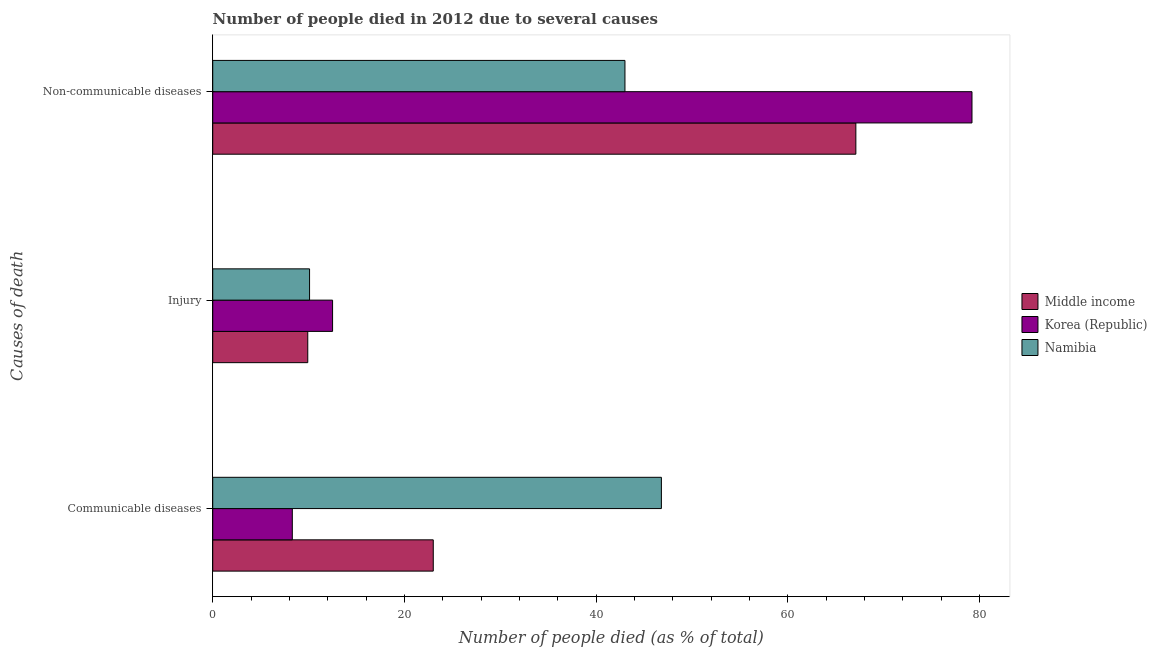How many different coloured bars are there?
Keep it short and to the point. 3. How many groups of bars are there?
Keep it short and to the point. 3. Are the number of bars per tick equal to the number of legend labels?
Keep it short and to the point. Yes. Are the number of bars on each tick of the Y-axis equal?
Your answer should be compact. Yes. How many bars are there on the 3rd tick from the bottom?
Your answer should be compact. 3. What is the label of the 2nd group of bars from the top?
Provide a short and direct response. Injury. What is the number of people who died of injury in Middle income?
Your answer should be compact. 9.91. In which country was the number of people who died of injury minimum?
Provide a succinct answer. Middle income. What is the total number of people who died of injury in the graph?
Give a very brief answer. 32.51. What is the difference between the number of people who died of communicable diseases in Korea (Republic) and that in Middle income?
Provide a succinct answer. -14.7. What is the difference between the number of people who died of injury in Korea (Republic) and the number of people who dies of non-communicable diseases in Middle income?
Offer a terse response. -54.59. What is the average number of people who died of communicable diseases per country?
Your answer should be very brief. 26.03. What is the difference between the number of people who dies of non-communicable diseases and number of people who died of communicable diseases in Korea (Republic)?
Your answer should be very brief. 70.9. In how many countries, is the number of people who died of injury greater than 4 %?
Keep it short and to the point. 3. What is the ratio of the number of people who dies of non-communicable diseases in Korea (Republic) to that in Middle income?
Provide a succinct answer. 1.18. What is the difference between the highest and the second highest number of people who died of communicable diseases?
Provide a short and direct response. 23.8. What is the difference between the highest and the lowest number of people who died of injury?
Make the answer very short. 2.59. In how many countries, is the number of people who dies of non-communicable diseases greater than the average number of people who dies of non-communicable diseases taken over all countries?
Offer a very short reply. 2. Is the sum of the number of people who died of injury in Middle income and Korea (Republic) greater than the maximum number of people who died of communicable diseases across all countries?
Keep it short and to the point. No. What does the 3rd bar from the top in Communicable diseases represents?
Your answer should be very brief. Middle income. What does the 2nd bar from the bottom in Communicable diseases represents?
Your answer should be very brief. Korea (Republic). Is it the case that in every country, the sum of the number of people who died of communicable diseases and number of people who died of injury is greater than the number of people who dies of non-communicable diseases?
Your response must be concise. No. Are all the bars in the graph horizontal?
Ensure brevity in your answer.  Yes. What is the difference between two consecutive major ticks on the X-axis?
Make the answer very short. 20. Does the graph contain any zero values?
Offer a very short reply. No. Does the graph contain grids?
Provide a succinct answer. No. Where does the legend appear in the graph?
Your response must be concise. Center right. What is the title of the graph?
Ensure brevity in your answer.  Number of people died in 2012 due to several causes. What is the label or title of the X-axis?
Make the answer very short. Number of people died (as % of total). What is the label or title of the Y-axis?
Offer a terse response. Causes of death. What is the Number of people died (as % of total) of Middle income in Communicable diseases?
Offer a very short reply. 23. What is the Number of people died (as % of total) of Korea (Republic) in Communicable diseases?
Provide a short and direct response. 8.3. What is the Number of people died (as % of total) of Namibia in Communicable diseases?
Offer a very short reply. 46.8. What is the Number of people died (as % of total) in Middle income in Injury?
Provide a succinct answer. 9.91. What is the Number of people died (as % of total) of Namibia in Injury?
Make the answer very short. 10.1. What is the Number of people died (as % of total) of Middle income in Non-communicable diseases?
Your answer should be very brief. 67.09. What is the Number of people died (as % of total) in Korea (Republic) in Non-communicable diseases?
Your answer should be compact. 79.2. What is the Number of people died (as % of total) in Namibia in Non-communicable diseases?
Offer a very short reply. 43. Across all Causes of death, what is the maximum Number of people died (as % of total) in Middle income?
Keep it short and to the point. 67.09. Across all Causes of death, what is the maximum Number of people died (as % of total) in Korea (Republic)?
Provide a short and direct response. 79.2. Across all Causes of death, what is the maximum Number of people died (as % of total) in Namibia?
Offer a very short reply. 46.8. Across all Causes of death, what is the minimum Number of people died (as % of total) in Middle income?
Give a very brief answer. 9.91. What is the total Number of people died (as % of total) in Middle income in the graph?
Your answer should be very brief. 100. What is the total Number of people died (as % of total) in Korea (Republic) in the graph?
Provide a succinct answer. 100. What is the total Number of people died (as % of total) in Namibia in the graph?
Keep it short and to the point. 99.9. What is the difference between the Number of people died (as % of total) of Middle income in Communicable diseases and that in Injury?
Keep it short and to the point. 13.09. What is the difference between the Number of people died (as % of total) of Namibia in Communicable diseases and that in Injury?
Provide a succinct answer. 36.7. What is the difference between the Number of people died (as % of total) of Middle income in Communicable diseases and that in Non-communicable diseases?
Keep it short and to the point. -44.08. What is the difference between the Number of people died (as % of total) of Korea (Republic) in Communicable diseases and that in Non-communicable diseases?
Your answer should be compact. -70.9. What is the difference between the Number of people died (as % of total) of Middle income in Injury and that in Non-communicable diseases?
Offer a very short reply. -57.17. What is the difference between the Number of people died (as % of total) of Korea (Republic) in Injury and that in Non-communicable diseases?
Provide a short and direct response. -66.7. What is the difference between the Number of people died (as % of total) of Namibia in Injury and that in Non-communicable diseases?
Your answer should be very brief. -32.9. What is the difference between the Number of people died (as % of total) in Middle income in Communicable diseases and the Number of people died (as % of total) in Korea (Republic) in Injury?
Make the answer very short. 10.5. What is the difference between the Number of people died (as % of total) of Middle income in Communicable diseases and the Number of people died (as % of total) of Namibia in Injury?
Provide a succinct answer. 12.9. What is the difference between the Number of people died (as % of total) of Korea (Republic) in Communicable diseases and the Number of people died (as % of total) of Namibia in Injury?
Provide a succinct answer. -1.8. What is the difference between the Number of people died (as % of total) of Middle income in Communicable diseases and the Number of people died (as % of total) of Korea (Republic) in Non-communicable diseases?
Keep it short and to the point. -56.2. What is the difference between the Number of people died (as % of total) of Middle income in Communicable diseases and the Number of people died (as % of total) of Namibia in Non-communicable diseases?
Make the answer very short. -20. What is the difference between the Number of people died (as % of total) in Korea (Republic) in Communicable diseases and the Number of people died (as % of total) in Namibia in Non-communicable diseases?
Ensure brevity in your answer.  -34.7. What is the difference between the Number of people died (as % of total) in Middle income in Injury and the Number of people died (as % of total) in Korea (Republic) in Non-communicable diseases?
Provide a succinct answer. -69.29. What is the difference between the Number of people died (as % of total) in Middle income in Injury and the Number of people died (as % of total) in Namibia in Non-communicable diseases?
Provide a short and direct response. -33.09. What is the difference between the Number of people died (as % of total) in Korea (Republic) in Injury and the Number of people died (as % of total) in Namibia in Non-communicable diseases?
Ensure brevity in your answer.  -30.5. What is the average Number of people died (as % of total) of Middle income per Causes of death?
Offer a very short reply. 33.33. What is the average Number of people died (as % of total) of Korea (Republic) per Causes of death?
Keep it short and to the point. 33.33. What is the average Number of people died (as % of total) in Namibia per Causes of death?
Your answer should be very brief. 33.3. What is the difference between the Number of people died (as % of total) of Middle income and Number of people died (as % of total) of Korea (Republic) in Communicable diseases?
Your answer should be very brief. 14.7. What is the difference between the Number of people died (as % of total) in Middle income and Number of people died (as % of total) in Namibia in Communicable diseases?
Ensure brevity in your answer.  -23.8. What is the difference between the Number of people died (as % of total) of Korea (Republic) and Number of people died (as % of total) of Namibia in Communicable diseases?
Make the answer very short. -38.5. What is the difference between the Number of people died (as % of total) in Middle income and Number of people died (as % of total) in Korea (Republic) in Injury?
Give a very brief answer. -2.59. What is the difference between the Number of people died (as % of total) of Middle income and Number of people died (as % of total) of Namibia in Injury?
Your answer should be very brief. -0.19. What is the difference between the Number of people died (as % of total) in Middle income and Number of people died (as % of total) in Korea (Republic) in Non-communicable diseases?
Offer a very short reply. -12.11. What is the difference between the Number of people died (as % of total) of Middle income and Number of people died (as % of total) of Namibia in Non-communicable diseases?
Your answer should be compact. 24.09. What is the difference between the Number of people died (as % of total) in Korea (Republic) and Number of people died (as % of total) in Namibia in Non-communicable diseases?
Keep it short and to the point. 36.2. What is the ratio of the Number of people died (as % of total) in Middle income in Communicable diseases to that in Injury?
Offer a terse response. 2.32. What is the ratio of the Number of people died (as % of total) in Korea (Republic) in Communicable diseases to that in Injury?
Your response must be concise. 0.66. What is the ratio of the Number of people died (as % of total) of Namibia in Communicable diseases to that in Injury?
Your answer should be very brief. 4.63. What is the ratio of the Number of people died (as % of total) of Middle income in Communicable diseases to that in Non-communicable diseases?
Give a very brief answer. 0.34. What is the ratio of the Number of people died (as % of total) of Korea (Republic) in Communicable diseases to that in Non-communicable diseases?
Provide a short and direct response. 0.1. What is the ratio of the Number of people died (as % of total) of Namibia in Communicable diseases to that in Non-communicable diseases?
Provide a succinct answer. 1.09. What is the ratio of the Number of people died (as % of total) in Middle income in Injury to that in Non-communicable diseases?
Provide a succinct answer. 0.15. What is the ratio of the Number of people died (as % of total) in Korea (Republic) in Injury to that in Non-communicable diseases?
Offer a terse response. 0.16. What is the ratio of the Number of people died (as % of total) in Namibia in Injury to that in Non-communicable diseases?
Keep it short and to the point. 0.23. What is the difference between the highest and the second highest Number of people died (as % of total) in Middle income?
Offer a very short reply. 44.08. What is the difference between the highest and the second highest Number of people died (as % of total) of Korea (Republic)?
Make the answer very short. 66.7. What is the difference between the highest and the second highest Number of people died (as % of total) of Namibia?
Keep it short and to the point. 3.8. What is the difference between the highest and the lowest Number of people died (as % of total) in Middle income?
Make the answer very short. 57.17. What is the difference between the highest and the lowest Number of people died (as % of total) of Korea (Republic)?
Offer a terse response. 70.9. What is the difference between the highest and the lowest Number of people died (as % of total) of Namibia?
Your answer should be very brief. 36.7. 